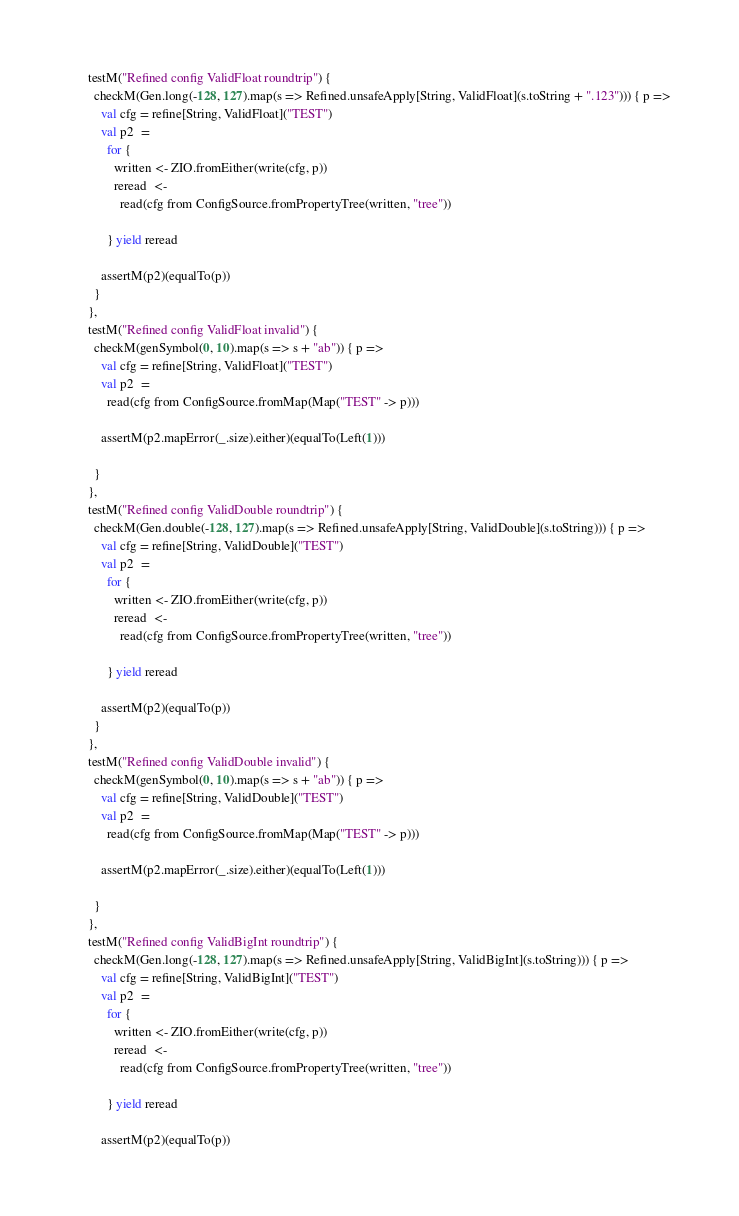Convert code to text. <code><loc_0><loc_0><loc_500><loc_500><_Scala_>      testM("Refined config ValidFloat roundtrip") {
        checkM(Gen.long(-128, 127).map(s => Refined.unsafeApply[String, ValidFloat](s.toString + ".123"))) { p =>
          val cfg = refine[String, ValidFloat]("TEST")
          val p2  =
            for {
              written <- ZIO.fromEither(write(cfg, p))
              reread  <-
                read(cfg from ConfigSource.fromPropertyTree(written, "tree"))

            } yield reread

          assertM(p2)(equalTo(p))
        }
      },
      testM("Refined config ValidFloat invalid") {
        checkM(genSymbol(0, 10).map(s => s + "ab")) { p =>
          val cfg = refine[String, ValidFloat]("TEST")
          val p2  =
            read(cfg from ConfigSource.fromMap(Map("TEST" -> p)))

          assertM(p2.mapError(_.size).either)(equalTo(Left(1)))

        }
      },
      testM("Refined config ValidDouble roundtrip") {
        checkM(Gen.double(-128, 127).map(s => Refined.unsafeApply[String, ValidDouble](s.toString))) { p =>
          val cfg = refine[String, ValidDouble]("TEST")
          val p2  =
            for {
              written <- ZIO.fromEither(write(cfg, p))
              reread  <-
                read(cfg from ConfigSource.fromPropertyTree(written, "tree"))

            } yield reread

          assertM(p2)(equalTo(p))
        }
      },
      testM("Refined config ValidDouble invalid") {
        checkM(genSymbol(0, 10).map(s => s + "ab")) { p =>
          val cfg = refine[String, ValidDouble]("TEST")
          val p2  =
            read(cfg from ConfigSource.fromMap(Map("TEST" -> p)))

          assertM(p2.mapError(_.size).either)(equalTo(Left(1)))

        }
      },
      testM("Refined config ValidBigInt roundtrip") {
        checkM(Gen.long(-128, 127).map(s => Refined.unsafeApply[String, ValidBigInt](s.toString))) { p =>
          val cfg = refine[String, ValidBigInt]("TEST")
          val p2  =
            for {
              written <- ZIO.fromEither(write(cfg, p))
              reread  <-
                read(cfg from ConfigSource.fromPropertyTree(written, "tree"))

            } yield reread

          assertM(p2)(equalTo(p))</code> 